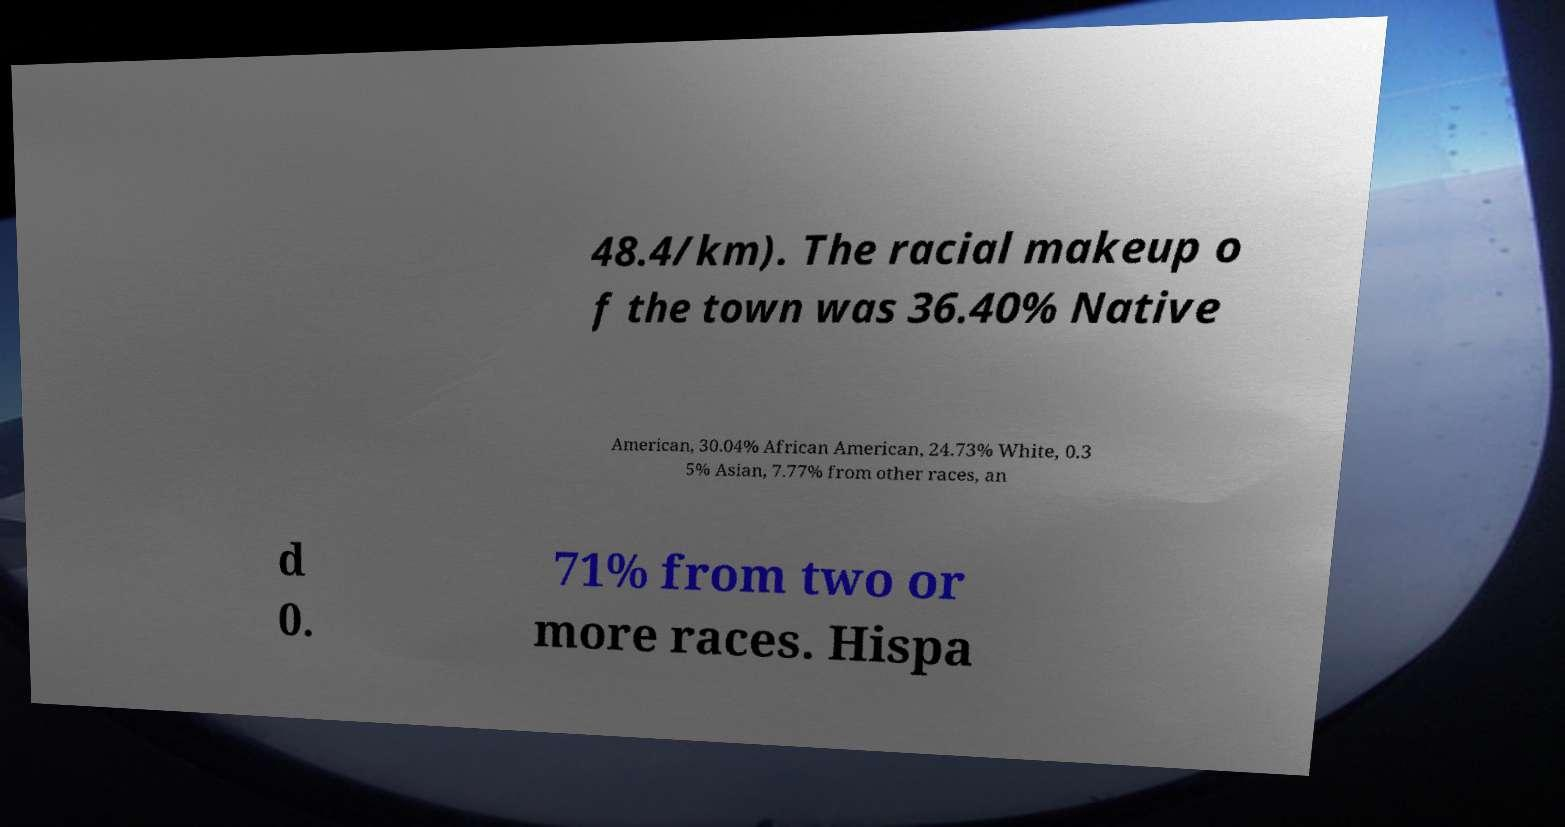Please read and relay the text visible in this image. What does it say? 48.4/km). The racial makeup o f the town was 36.40% Native American, 30.04% African American, 24.73% White, 0.3 5% Asian, 7.77% from other races, an d 0. 71% from two or more races. Hispa 